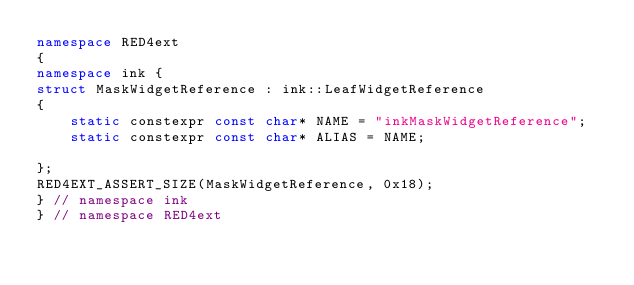Convert code to text. <code><loc_0><loc_0><loc_500><loc_500><_C++_>namespace RED4ext
{
namespace ink { 
struct MaskWidgetReference : ink::LeafWidgetReference
{
    static constexpr const char* NAME = "inkMaskWidgetReference";
    static constexpr const char* ALIAS = NAME;

};
RED4EXT_ASSERT_SIZE(MaskWidgetReference, 0x18);
} // namespace ink
} // namespace RED4ext
</code> 